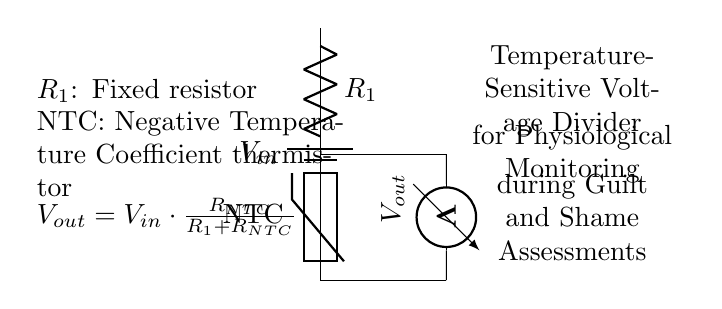What is the type of the thermistor used? The circuit shows that the thermistor is labeled as "NTC," indicating it is a Negative Temperature Coefficient thermistor. This means its resistance decreases with an increase in temperature.
Answer: NTC What does the output voltage depend on? The output voltage \(V_{out}\) is given by the formula \(V_{out} = V_{in} \cdot \frac{R_{NTC}}{R_1 + R_{NTC}}\). This indicates that it depends on the input voltage \(V_{in}\), the resistance of the fixed resistor \(R_1\), and the resistance of the thermistor \(R_{NTC}\).
Answer: Resistance and input voltage What happens to the output voltage if the temperature increases? As temperature increases, the resistance of the NTC thermistor decreases, which causes the proportion of \(R_{NTC}\) in the voltage divider formula to change, leading to an increase in output voltage \(V_{out}\).
Answer: Increases What is the function of the fixed resistor in this circuit? The fixed resistor \(R_1\) limits the total resistance in the circuit and helps establish a reference voltage for the output. It determines how the changes in \(R_{NTC}\) affect \(V_{out}\).
Answer: Sets reference voltage What is the purpose of the voltage divider in physiological monitoring? The voltage divider measures changes in the output voltage corresponding to physiological temperature changes during guilt and shame assessments, which may indicate emotional states.
Answer: Monitor emotional states What is displayed on the voltmeter? The voltmeter is connected to \(V_{out}\), which shows the voltage signal resulting from the voltage division between \(R_1\) and \(R_{NTC}\).
Answer: Output voltage 